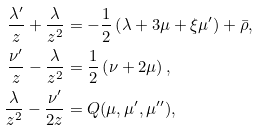<formula> <loc_0><loc_0><loc_500><loc_500>\frac { \lambda ^ { \prime } } { z } + \frac { \lambda } { z ^ { 2 } } & = - \frac { 1 } { 2 } \left ( \lambda + 3 \mu + \xi \mu ^ { \prime } \right ) + \bar { \rho } , \\ \frac { \nu ^ { \prime } } { z } - \frac { \lambda } { z ^ { 2 } } & = \frac { 1 } { 2 } \left ( \nu + 2 \mu \right ) , \\ \frac { \lambda } { z ^ { 2 } } - \frac { \nu ^ { \prime } } { 2 z } & = Q ( \mu , \mu ^ { \prime } , \mu ^ { \prime \prime } ) ,</formula> 